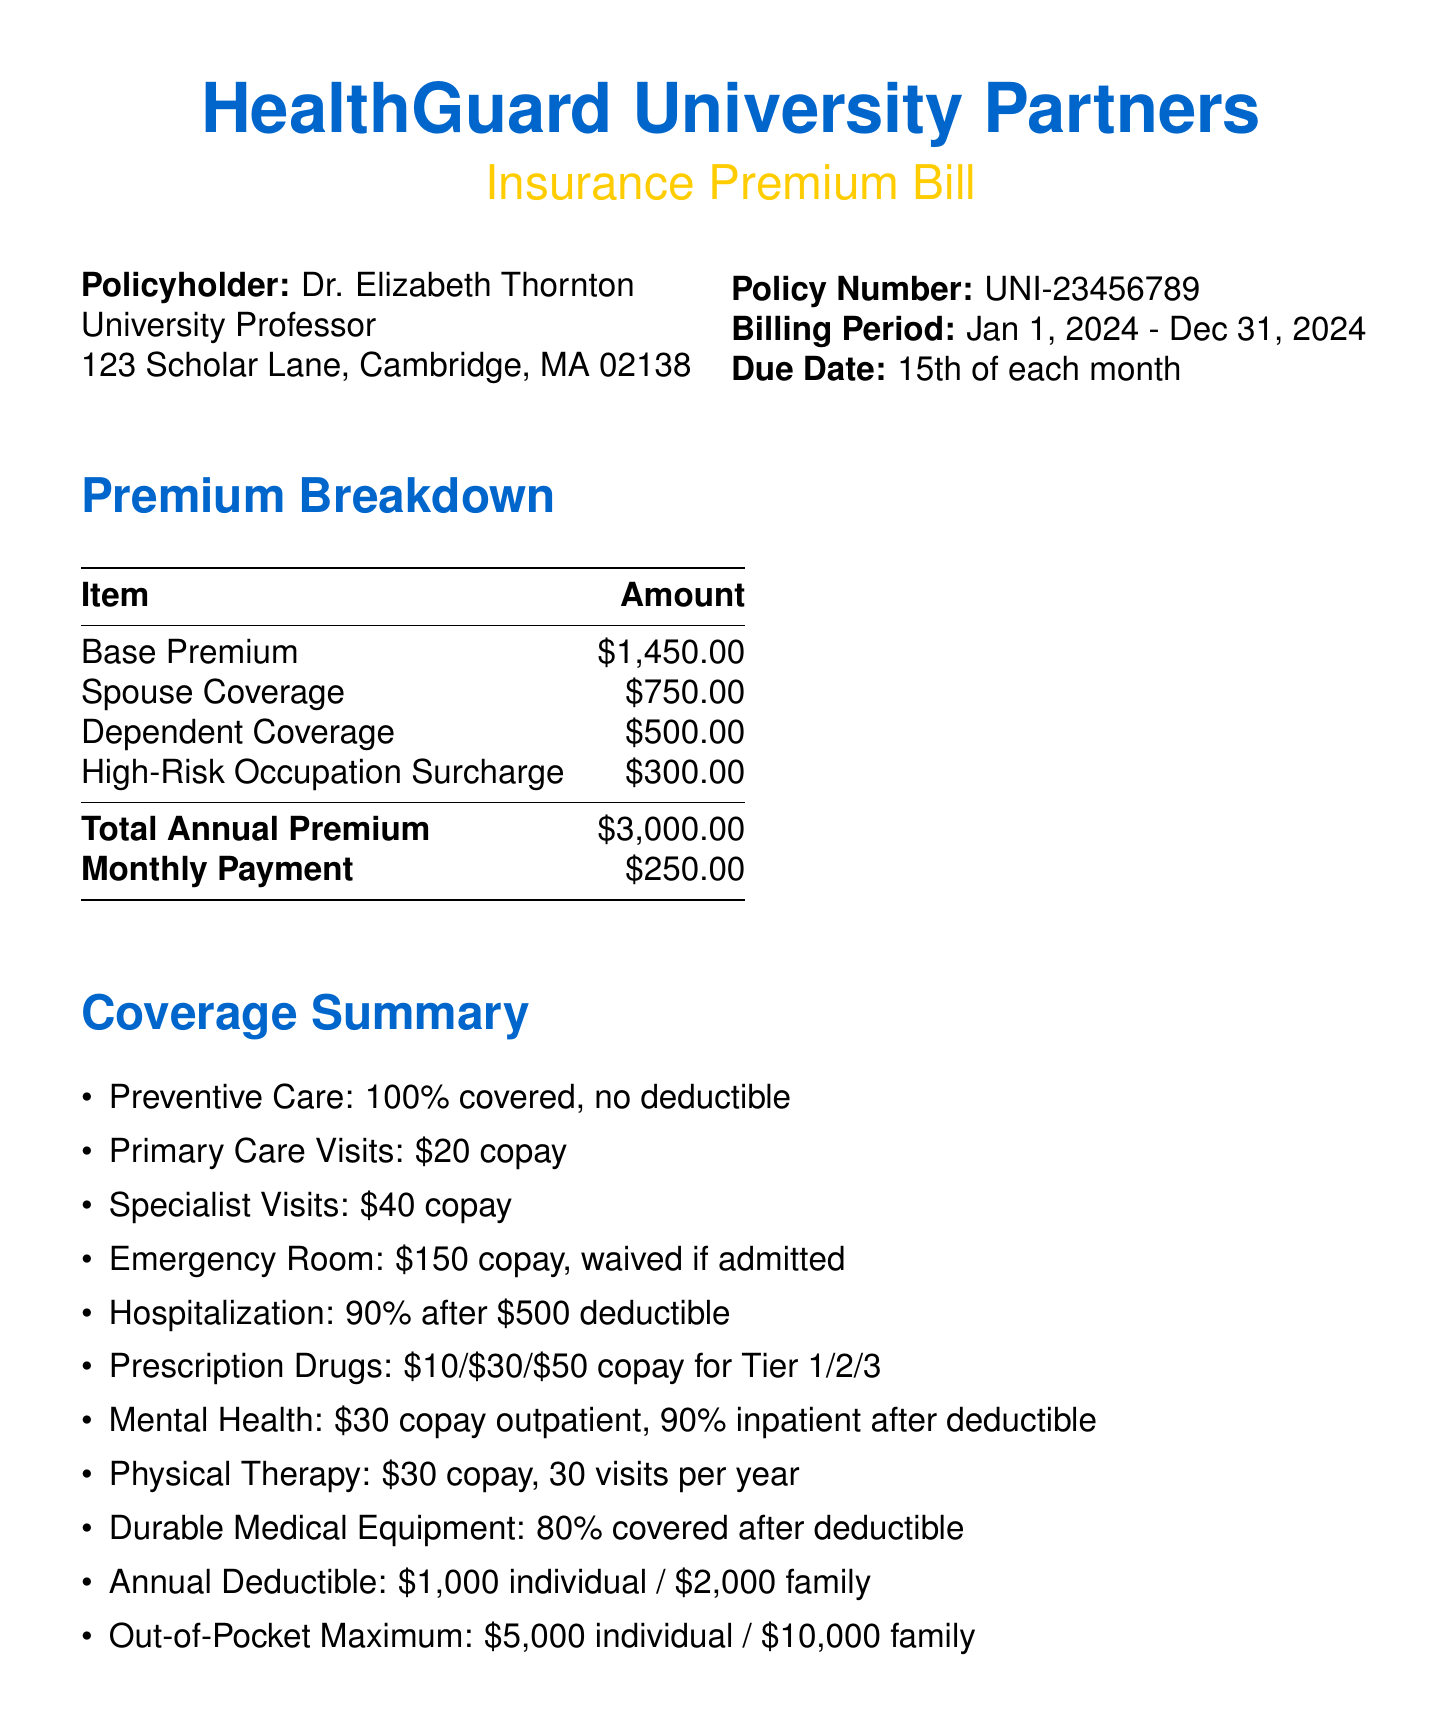What is the policyholder's name? The policyholder's name is stated at the top of the document.
Answer: Dr. Elizabeth Thornton What is the total annual premium? The total annual premium is calculated based on the premium breakdown provided.
Answer: $3,000.00 What is the due date for the bill? The due date is mentioned in the billing information section.
Answer: 15th of each month How much is the copay for primary care visits? The copay amount for primary care visits is specified under the coverage summary.
Answer: $20 What is the annual deductible for family coverage? The deductible amount is provided in the annual deductible section.
Answer: $2,000 How many physical therapy visits are covered per year? The number of covered visits for physical therapy is listed in the coverage summary.
Answer: 30 visits What is included in the additional features of the plan? The additional features are outlined in a separate section of the document.
Answer: Telemedicine Services What is the out-of-pocket maximum for individual coverage? The out-of-pocket maximum is detailed in the coverage summary.
Answer: $5,000 What percentage of hospitalization costs is covered after the deductible? The coverage percentage for hospitalization is specified in the document.
Answer: 90% What is the contact number for questions regarding the bill? The contact number is provided in the note to the policyholder at the end of the document.
Answer: 1-800-HEALTH-UNI 